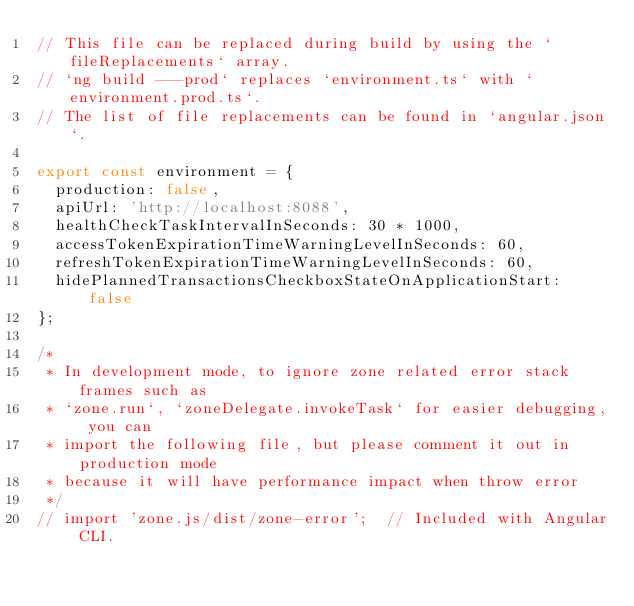Convert code to text. <code><loc_0><loc_0><loc_500><loc_500><_TypeScript_>// This file can be replaced during build by using the `fileReplacements` array.
// `ng build ---prod` replaces `environment.ts` with `environment.prod.ts`.
// The list of file replacements can be found in `angular.json`.

export const environment = {
  production: false,
  apiUrl: 'http://localhost:8088',
  healthCheckTaskIntervalInSeconds: 30 * 1000,
  accessTokenExpirationTimeWarningLevelInSeconds: 60,
  refreshTokenExpirationTimeWarningLevelInSeconds: 60,
  hidePlannedTransactionsCheckboxStateOnApplicationStart: false
};

/*
 * In development mode, to ignore zone related error stack frames such as
 * `zone.run`, `zoneDelegate.invokeTask` for easier debugging, you can
 * import the following file, but please comment it out in production mode
 * because it will have performance impact when throw error
 */
// import 'zone.js/dist/zone-error';  // Included with Angular CLI.
</code> 